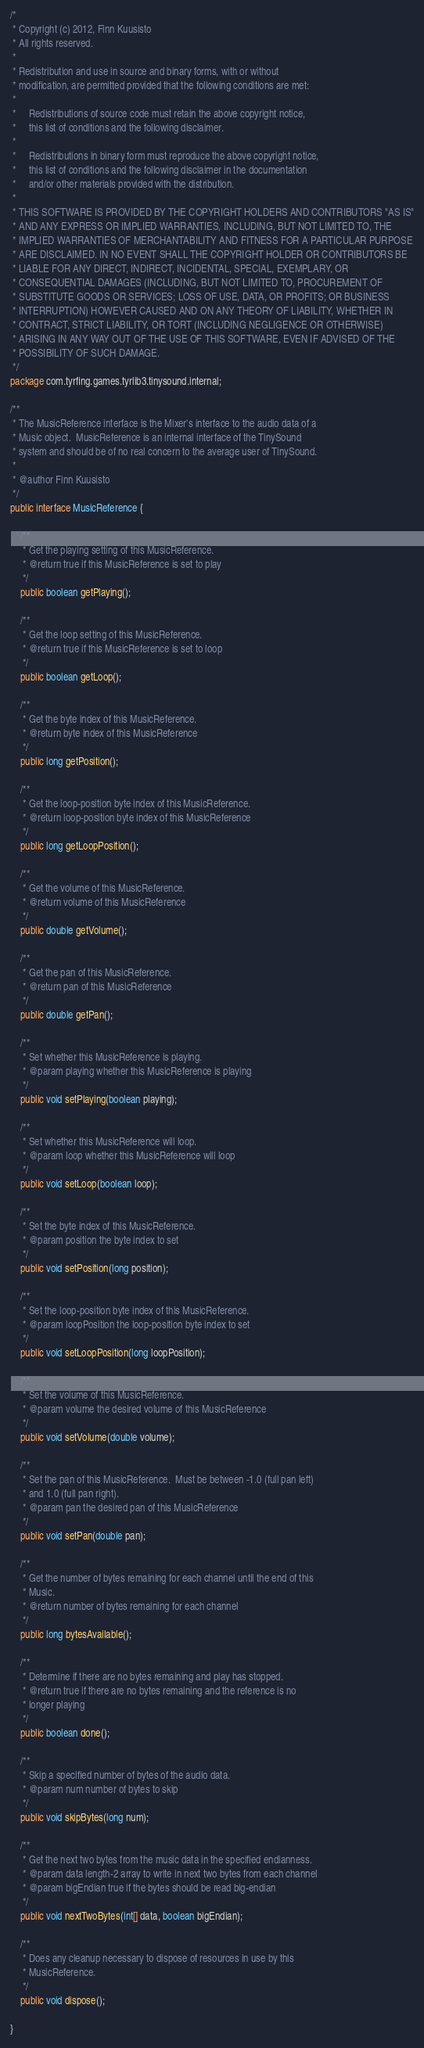Convert code to text. <code><loc_0><loc_0><loc_500><loc_500><_Java_>/*
 * Copyright (c) 2012, Finn Kuusisto
 * All rights reserved.
 *
 * Redistribution and use in source and binary forms, with or without
 * modification, are permitted provided that the following conditions are met:
 *
 *     Redistributions of source code must retain the above copyright notice,
 *     this list of conditions and the following disclaimer.
 *     
 *     Redistributions in binary form must reproduce the above copyright notice,
 *     this list of conditions and the following disclaimer in the documentation
 *     and/or other materials provided with the distribution.
 *
 * THIS SOFTWARE IS PROVIDED BY THE COPYRIGHT HOLDERS AND CONTRIBUTORS "AS IS"
 * AND ANY EXPRESS OR IMPLIED WARRANTIES, INCLUDING, BUT NOT LIMITED TO, THE
 * IMPLIED WARRANTIES OF MERCHANTABILITY AND FITNESS FOR A PARTICULAR PURPOSE
 * ARE DISCLAIMED. IN NO EVENT SHALL THE COPYRIGHT HOLDER OR CONTRIBUTORS BE
 * LIABLE FOR ANY DIRECT, INDIRECT, INCIDENTAL, SPECIAL, EXEMPLARY, OR
 * CONSEQUENTIAL DAMAGES (INCLUDING, BUT NOT LIMITED TO, PROCUREMENT OF
 * SUBSTITUTE GOODS OR SERVICES; LOSS OF USE, DATA, OR PROFITS; OR BUSINESS
 * INTERRUPTION) HOWEVER CAUSED AND ON ANY THEORY OF LIABILITY, WHETHER IN
 * CONTRACT, STRICT LIABILITY, OR TORT (INCLUDING NEGLIGENCE OR OTHERWISE)
 * ARISING IN ANY WAY OUT OF THE USE OF THIS SOFTWARE, EVEN IF ADVISED OF THE
 * POSSIBILITY OF SUCH DAMAGE.
 */
package com.tyrfing.games.tyrlib3.tinysound.internal;

/**
 * The MusicReference interface is the Mixer's interface to the audio data of a 
 * Music object.  MusicReference is an internal interface of the TinySound
 * system and should be of no real concern to the average user of TinySound.
 * 
 * @author Finn Kuusisto
 */
public interface MusicReference {

	/**
	 * Get the playing setting of this MusicReference.
	 * @return true if this MusicReference is set to play
	 */
	public boolean getPlaying();
	
	/**
	 * Get the loop setting of this MusicReference.
	 * @return true if this MusicReference is set to loop
	 */
	public boolean getLoop();
	
	/**
	 * Get the byte index of this MusicReference.
	 * @return byte index of this MusicReference
	 */
	public long getPosition();
	
	/**
	 * Get the loop-position byte index of this MusicReference.
	 * @return loop-position byte index of this MusicReference
	 */
	public long getLoopPosition();
	
	/**
	 * Get the volume of this MusicReference.
	 * @return volume of this MusicReference
	 */
	public double getVolume();
	
	/**
	 * Get the pan of this MusicReference.
	 * @return pan of this MusicReference
	 */
	public double getPan();
	
	/**
	 * Set whether this MusicReference is playing.
	 * @param playing whether this MusicReference is playing
	 */
	public void setPlaying(boolean playing);
	
	/**
	 * Set whether this MusicReference will loop.
	 * @param loop whether this MusicReference will loop
	 */
	public void setLoop(boolean loop);
	
	/**
	 * Set the byte index of this MusicReference.
	 * @param position the byte index to set
	 */
	public void setPosition(long position);
	
	/**
	 * Set the loop-position byte index of this MusicReference.
	 * @param loopPosition the loop-position byte index to set
	 */
	public void setLoopPosition(long loopPosition);
	
	/**
	 * Set the volume of this MusicReference.
	 * @param volume the desired volume of this MusicReference
	 */
	public void setVolume(double volume);
	
	/**
	 * Set the pan of this MusicReference.  Must be between -1.0 (full pan left)
	 * and 1.0 (full pan right).
	 * @param pan the desired pan of this MusicReference
	 */
	public void setPan(double pan);
	
	/**
	 * Get the number of bytes remaining for each channel until the end of this
	 * Music.
	 * @return number of bytes remaining for each channel
	 */
	public long bytesAvailable();
	
	/**
	 * Determine if there are no bytes remaining and play has stopped.
	 * @return true if there are no bytes remaining and the reference is no
	 * longer playing
	 */
	public boolean done();
	
	/**
	 * Skip a specified number of bytes of the audio data.
	 * @param num number of bytes to skip
	 */
	public void skipBytes(long num);
	
	/**
	 * Get the next two bytes from the music data in the specified endianness.
	 * @param data length-2 array to write in next two bytes from each channel
	 * @param bigEndian true if the bytes should be read big-endian
	 */
	public void nextTwoBytes(int[] data, boolean bigEndian);
	
	/**
	 * Does any cleanup necessary to dispose of resources in use by this
	 * MusicReference.
	 */
	public void dispose();
	
}
</code> 